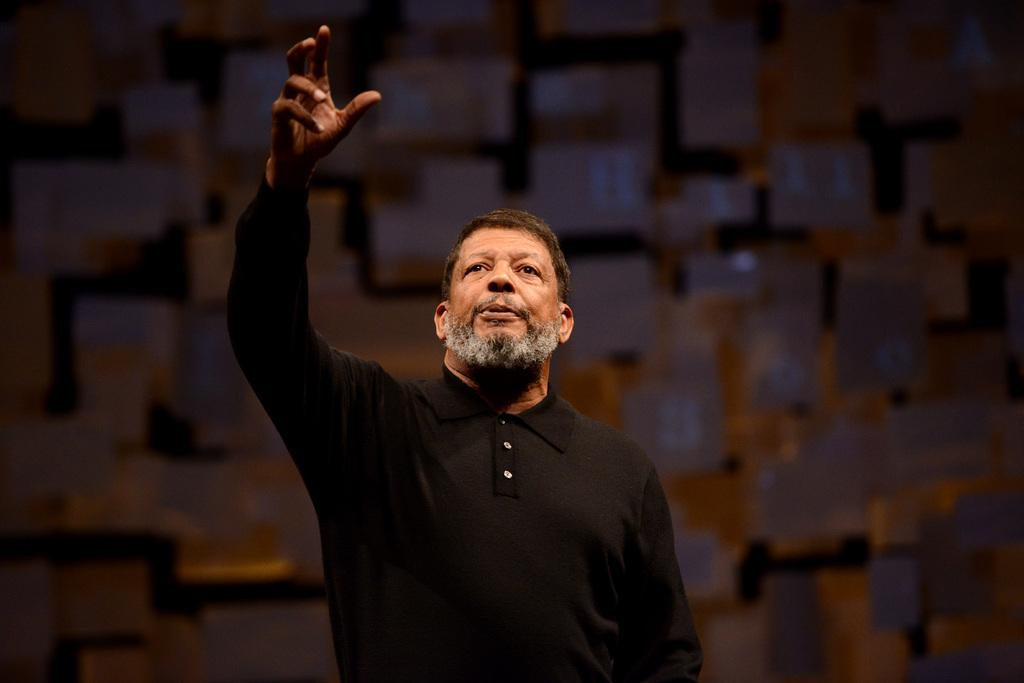What is the main subject of the image? There is a man in the image. What is the man wearing in the image? The man is wearing a black t-shirt. Can you describe the quality of the background in the image? The image is blurry in the background. What type of paste is being used by the man in the image? There is no paste present in the image, and the man is not using any paste. What scientific experiment is being conducted in the image? There is no scientific experiment depicted in the image. 